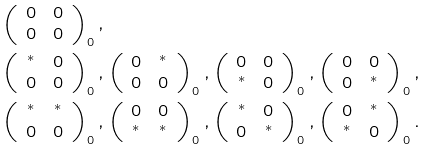Convert formula to latex. <formula><loc_0><loc_0><loc_500><loc_500>& \left ( \begin{array} [ c ] { c c } 0 & 0 \\ 0 & 0 \end{array} \right ) _ { 0 } , \\ & \left ( \begin{array} [ c ] { c c } ^ { * } & 0 \\ 0 & 0 \end{array} \right ) _ { 0 } , \left ( \begin{array} [ c ] { c c } 0 & ^ { * } \\ 0 & 0 \end{array} \right ) _ { 0 } , \left ( \begin{array} [ c ] { c c } 0 & 0 \\ ^ { * } & 0 \end{array} \right ) _ { 0 } , \left ( \begin{array} [ c ] { c c } 0 & 0 \\ 0 & ^ { * } \end{array} \right ) _ { 0 } , \\ & \left ( \begin{array} [ c ] { c c } ^ { * } & ^ { * } \\ 0 & 0 \end{array} \right ) _ { 0 } , \left ( \begin{array} [ c ] { c c } 0 & 0 \\ ^ { * } & ^ { * } \end{array} \right ) _ { 0 } , \left ( \begin{array} [ c ] { c c } ^ { * } & 0 \\ 0 & ^ { * } \end{array} \right ) _ { 0 } , \left ( \begin{array} [ c ] { c c } 0 & ^ { * } \\ ^ { * } & 0 \end{array} \right ) _ { 0 } .</formula> 